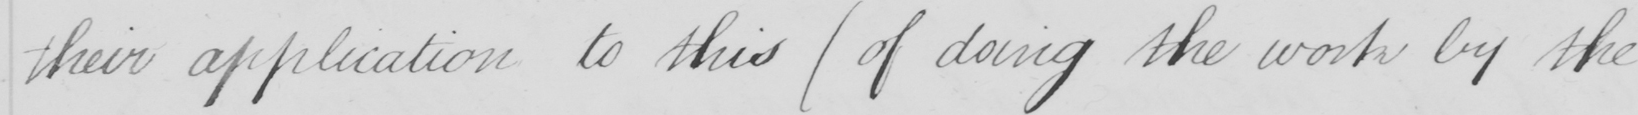What is written in this line of handwriting? their application to this  ( of doing the work by the 